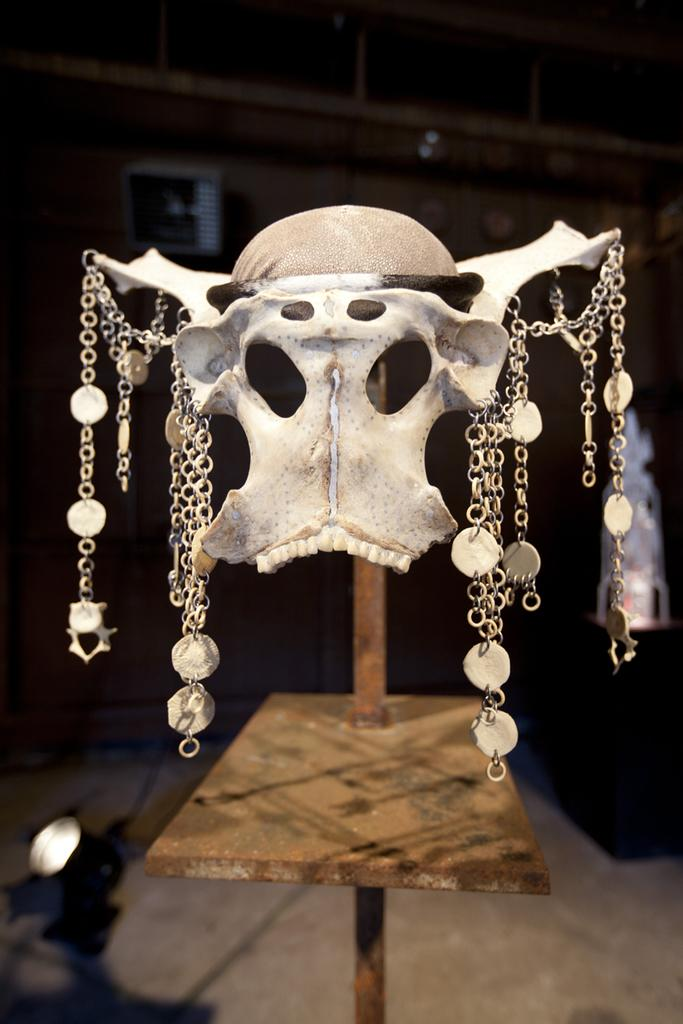What is the main object or structure in the image? There is a table in the image. What is placed on the table? A skeleton is present on the table. Are there any additional features or accessories associated with the skeleton? Yes, the skeleton has chains. What is the color of the background in the image? The background of the image is black. What type of stew is being prepared on the table in the image? There is no stew present in the image; it features a table with a skeleton and chains. Can you tell me how many people are participating in the protest in the image? There is no protest depicted in the image; it features a table with a skeleton and chains against a black background. 